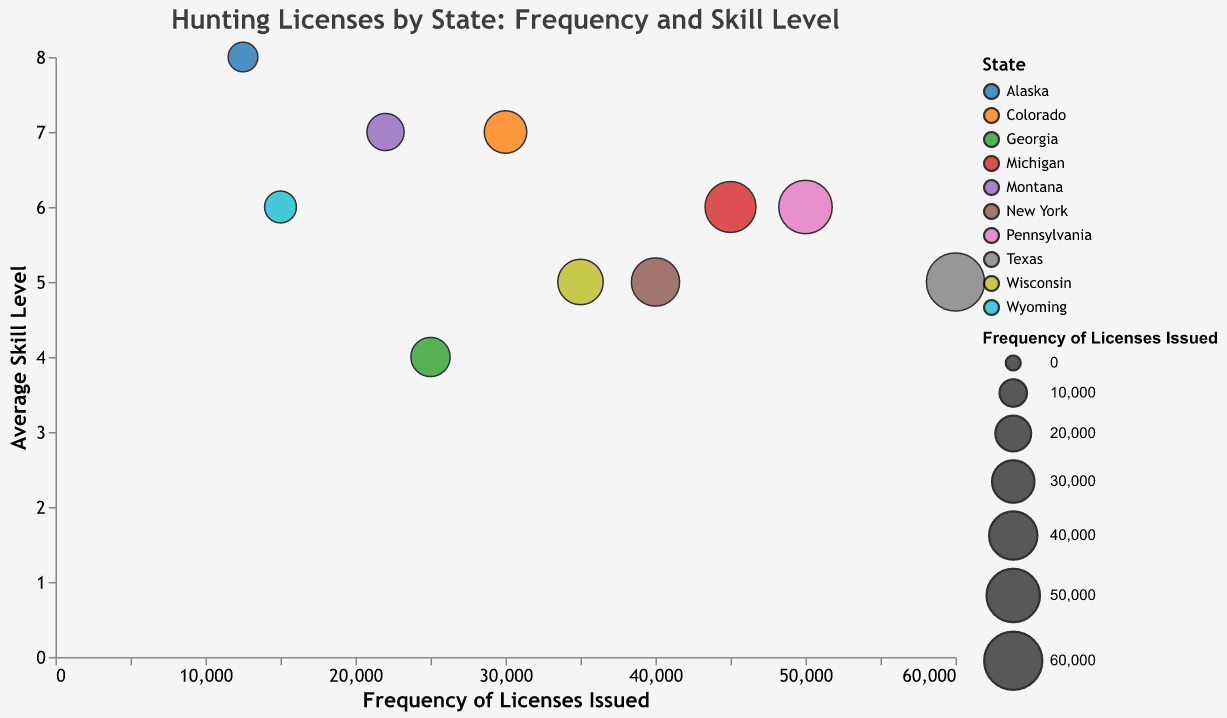What's the title of the chart? The title of the chart is displayed at the top center, usually in a larger font size. It reads "Hunting Licenses by State: Frequency and Skill Level."
Answer: Hunting Licenses by State: Frequency and Skill Level How many states are represented in this Bubble Chart? Each bubble represents a state, and there are a total of 10 different bubbles in the chart.
Answer: 10 Which state has the highest frequency of licenses issued? The bubble with the largest size represents the highest frequency of licenses issued. Texas has the largest bubble, indicating it has the highest frequency.
Answer: Texas What is the average skill level for Pennsylvania? By hovering over the bubble representing Pennsylvania or observing the tooltip, we can see that the average skill level for Pennsylvania is 6.
Answer: 6 Compare the skill levels of states with frequencies above 40,000 licenses issued. The states with frequencies above 40,000 licenses are Texas, Michigan, Pennsylvania, and New York. The skill levels for these states are 5, 6, 6, and 5, respectively.
Answer: Texas: 5, Michigan: 6, Pennsylvania: 6, New York: 5 Which state has the highest average skill level and what is its frequency of licenses issued? The highest average skill level is represented by the bubble situated furthest up the y-axis. Alaska, with an average skill level of 8, has the highest skill level and its frequency of licenses issued is 12,500.
Answer: Alaska, 12,500 Calculate the total frequency of licenses issued for states with an average skill level of 6. The states with an average skill level of 6 are Michigan, Wyoming, and Pennsylvania. Adding their frequencies: Michigan (45,000) + Wyoming (15,000) + Pennsylvania (50,000) = 110,000.
Answer: 110,000 How does Colorado’s frequency of licenses and skill level compare to Wyoming's? Colorado has a frequency of 30,000 licenses and an average skill level of 7. Wyoming has a frequency of 15,000 licenses and an average skill level of 6. Colorado has a higher frequency and skill level compared to Wyoming.
Answer: Higher frequencies and skill levels What can you infer about the relationship between frequency of licenses issued and average skill levels? Observing the chart, there is no clear linear relationship between frequency and skill level. Some states with high frequencies (like Texas) have lower skill levels, while others with lower frequencies (like Alaska) have higher skill levels.
Answer: No clear linear relationship Identify the state with the lowest average skill level and mention its frequency. The bubble positioned lowest on the y-axis indicates the lowest average skill level. Georgia has the lowest average skill level of 4, with a frequency of 25,000 licenses issued.
Answer: Georgia, 25,000 